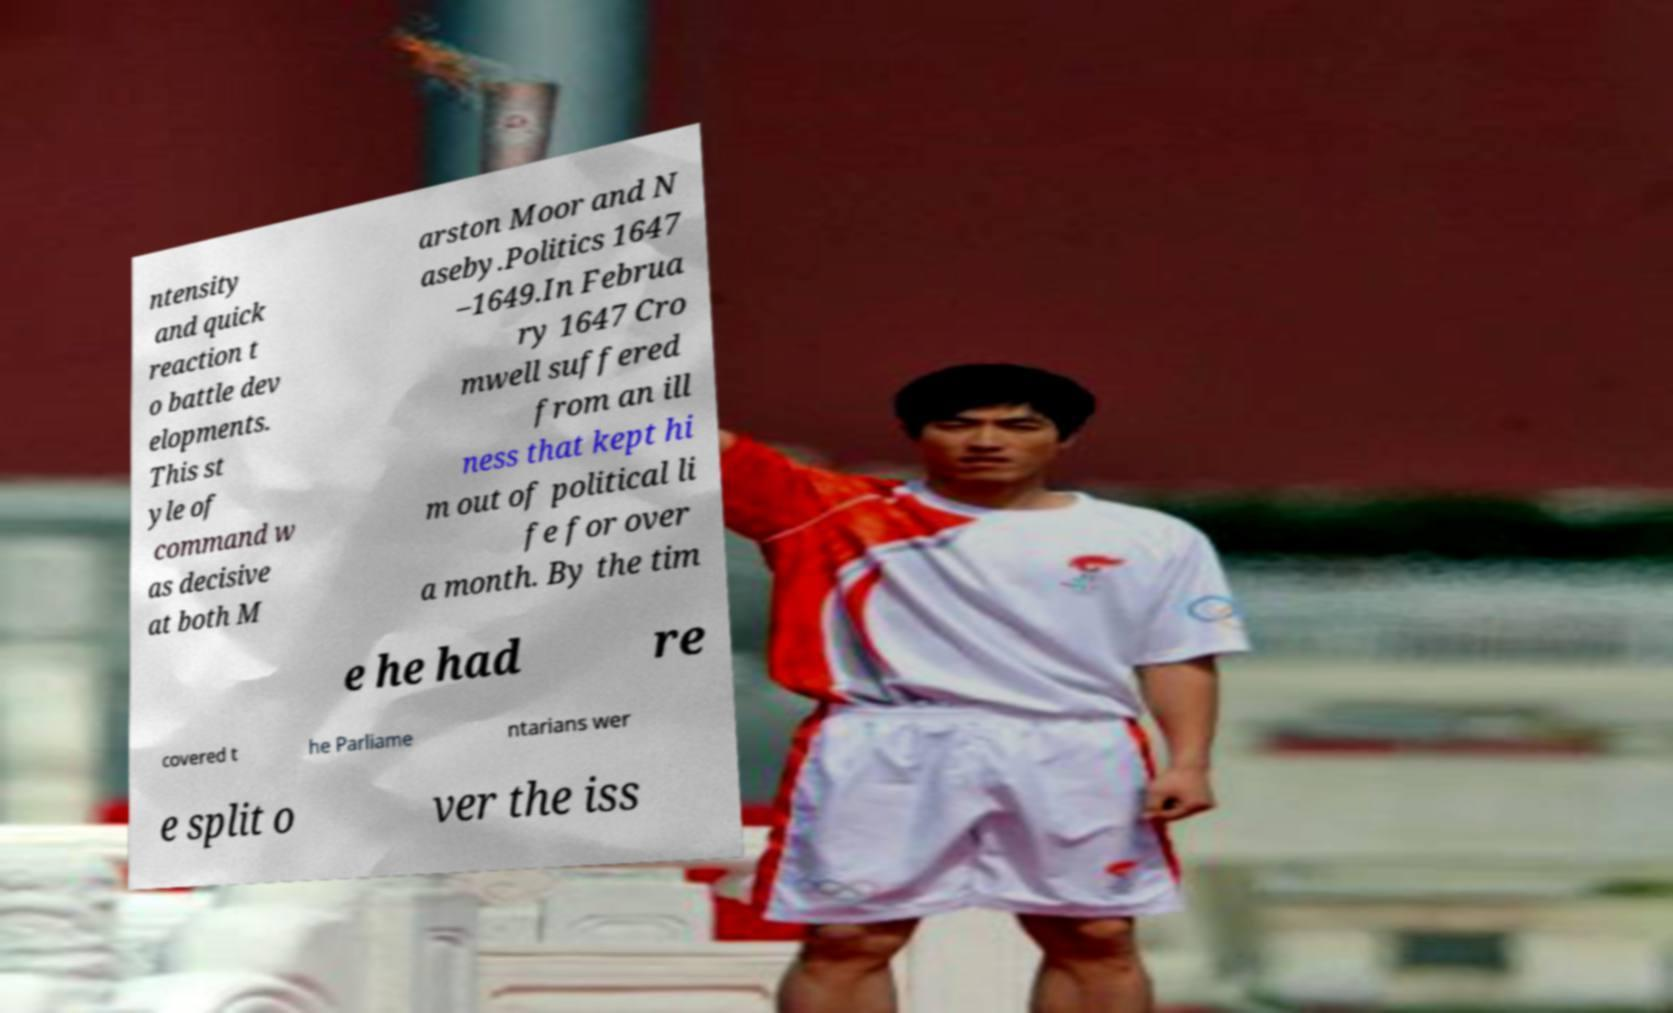Please identify and transcribe the text found in this image. ntensity and quick reaction t o battle dev elopments. This st yle of command w as decisive at both M arston Moor and N aseby.Politics 1647 –1649.In Februa ry 1647 Cro mwell suffered from an ill ness that kept hi m out of political li fe for over a month. By the tim e he had re covered t he Parliame ntarians wer e split o ver the iss 